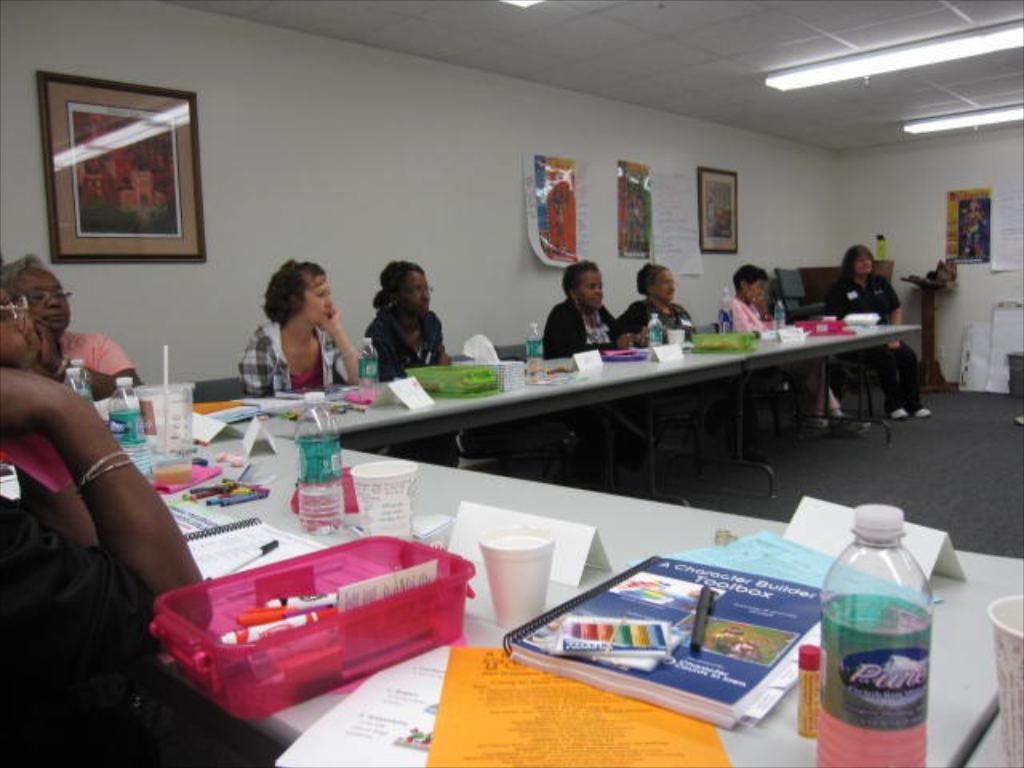In one or two sentences, can you explain what this image depicts? In this image we can see the people sitting on the chairs near the table. On the table there are books, bottles, papers, cups, pens and few objects. On the right side, we can see the board, stand and a few objects. In the background there are photo frames and banners attached to the wall. 